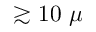<formula> <loc_0><loc_0><loc_500><loc_500>\gtrsim 1 0 \mu</formula> 